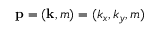Convert formula to latex. <formula><loc_0><loc_0><loc_500><loc_500>p = ( k , m ) = ( k _ { x } , k _ { y } , m )</formula> 